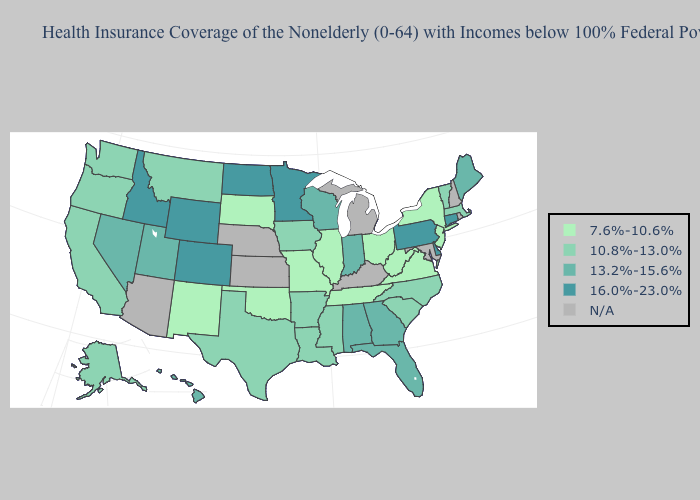Which states have the highest value in the USA?
Be succinct. Colorado, Connecticut, Delaware, Idaho, Minnesota, North Dakota, Pennsylvania, Wyoming. What is the value of Arkansas?
Quick response, please. 10.8%-13.0%. Which states hav the highest value in the South?
Write a very short answer. Delaware. Name the states that have a value in the range N/A?
Short answer required. Arizona, Kansas, Kentucky, Maryland, Michigan, Nebraska, New Hampshire, Rhode Island. What is the highest value in states that border Nebraska?
Quick response, please. 16.0%-23.0%. What is the value of Colorado?
Concise answer only. 16.0%-23.0%. What is the value of Mississippi?
Answer briefly. 10.8%-13.0%. Does the first symbol in the legend represent the smallest category?
Answer briefly. Yes. Name the states that have a value in the range N/A?
Keep it brief. Arizona, Kansas, Kentucky, Maryland, Michigan, Nebraska, New Hampshire, Rhode Island. Name the states that have a value in the range 16.0%-23.0%?
Answer briefly. Colorado, Connecticut, Delaware, Idaho, Minnesota, North Dakota, Pennsylvania, Wyoming. Among the states that border Minnesota , does North Dakota have the highest value?
Keep it brief. Yes. What is the lowest value in the USA?
Keep it brief. 7.6%-10.6%. What is the lowest value in the USA?
Give a very brief answer. 7.6%-10.6%. 